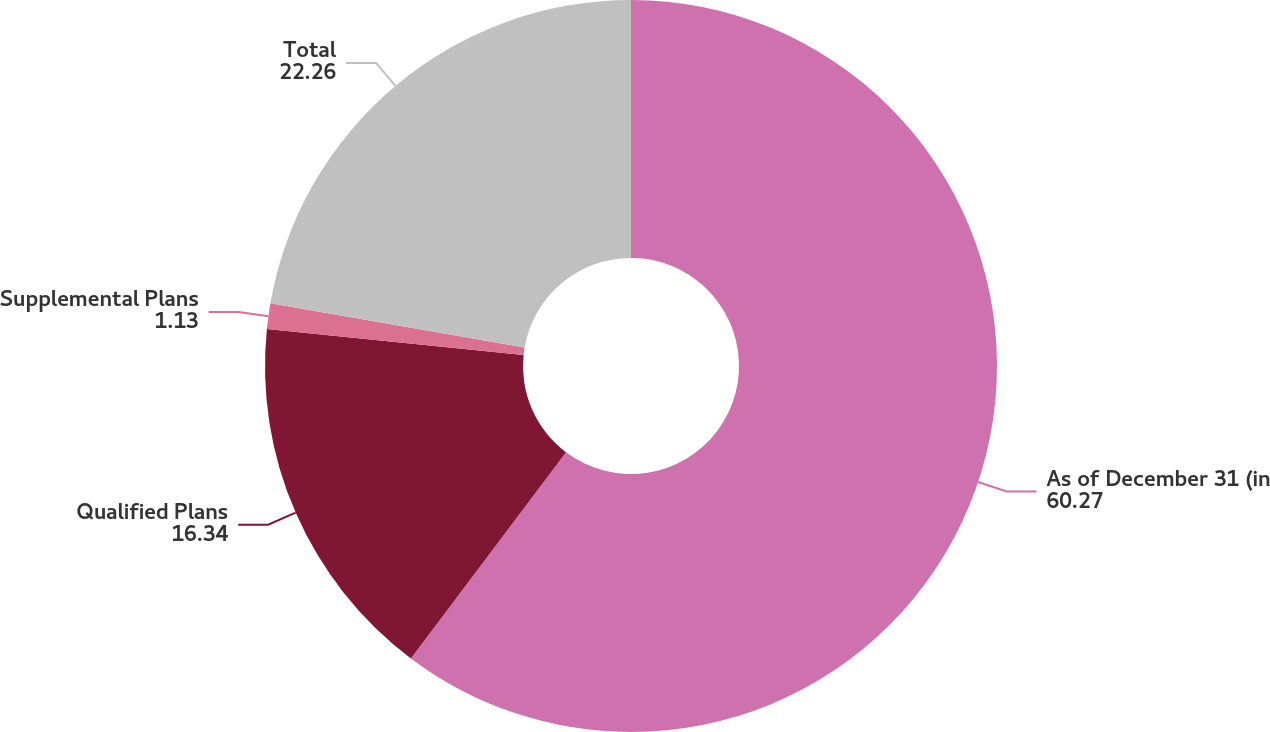Convert chart. <chart><loc_0><loc_0><loc_500><loc_500><pie_chart><fcel>As of December 31 (in<fcel>Qualified Plans<fcel>Supplemental Plans<fcel>Total<nl><fcel>60.27%<fcel>16.34%<fcel>1.13%<fcel>22.26%<nl></chart> 